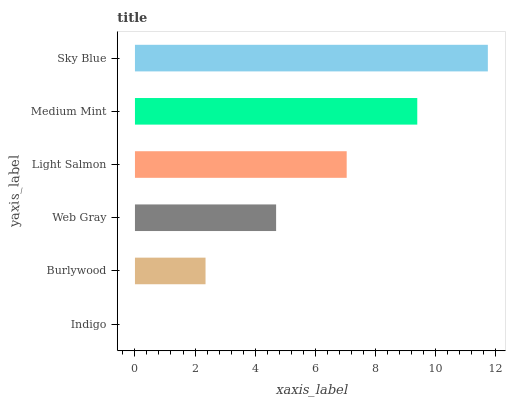Is Indigo the minimum?
Answer yes or no. Yes. Is Sky Blue the maximum?
Answer yes or no. Yes. Is Burlywood the minimum?
Answer yes or no. No. Is Burlywood the maximum?
Answer yes or no. No. Is Burlywood greater than Indigo?
Answer yes or no. Yes. Is Indigo less than Burlywood?
Answer yes or no. Yes. Is Indigo greater than Burlywood?
Answer yes or no. No. Is Burlywood less than Indigo?
Answer yes or no. No. Is Light Salmon the high median?
Answer yes or no. Yes. Is Web Gray the low median?
Answer yes or no. Yes. Is Medium Mint the high median?
Answer yes or no. No. Is Light Salmon the low median?
Answer yes or no. No. 